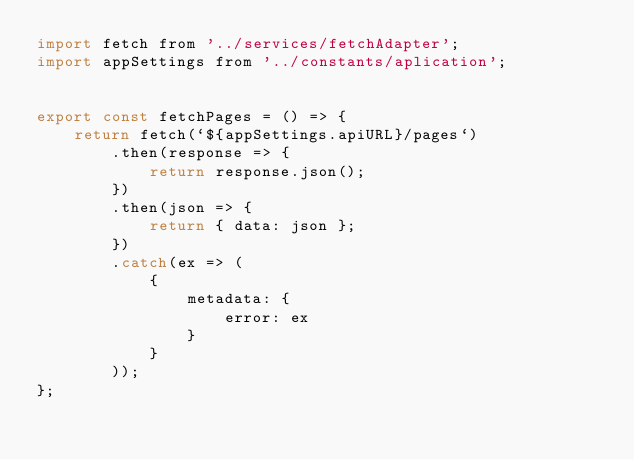<code> <loc_0><loc_0><loc_500><loc_500><_JavaScript_>import fetch from '../services/fetchAdapter';
import appSettings from '../constants/aplication';


export const fetchPages = () => {
    return fetch(`${appSettings.apiURL}/pages`)
        .then(response => {
            return response.json();
        })
        .then(json => {
            return { data: json };
        })
        .catch(ex => (
            {
                metadata: {
                    error: ex
                }
            }
        ));
};</code> 